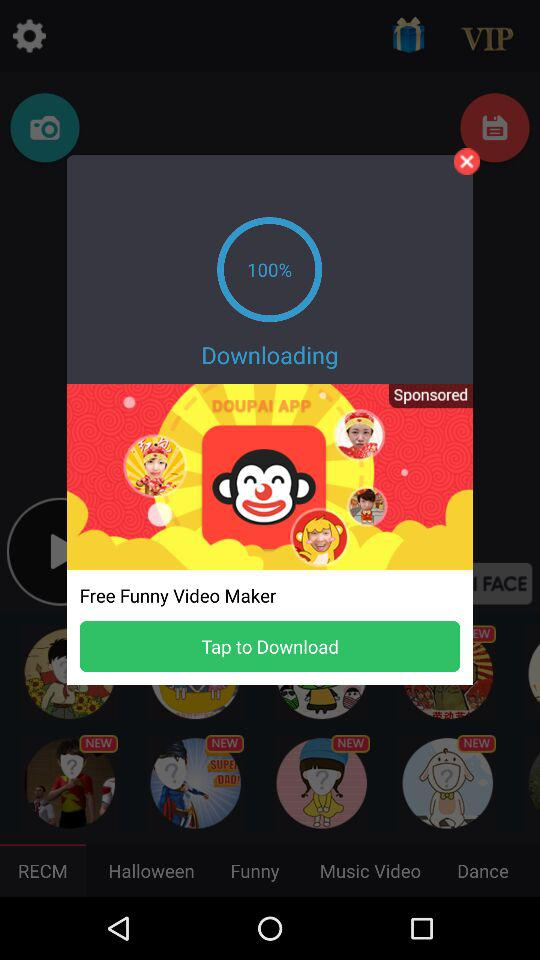How much of a percentage has been downloaded? The downloaded percentage is 100. 